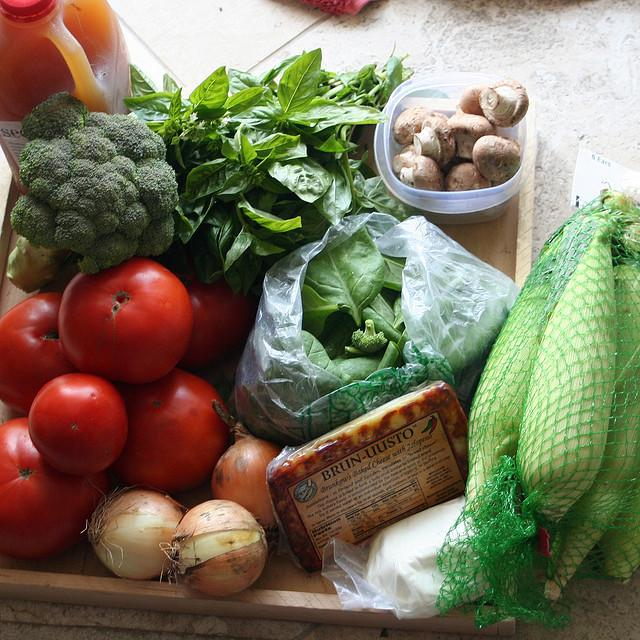What category of food is this?

Choices:
A) vegetables
B) grains
C) meats
D) taco vegetables 